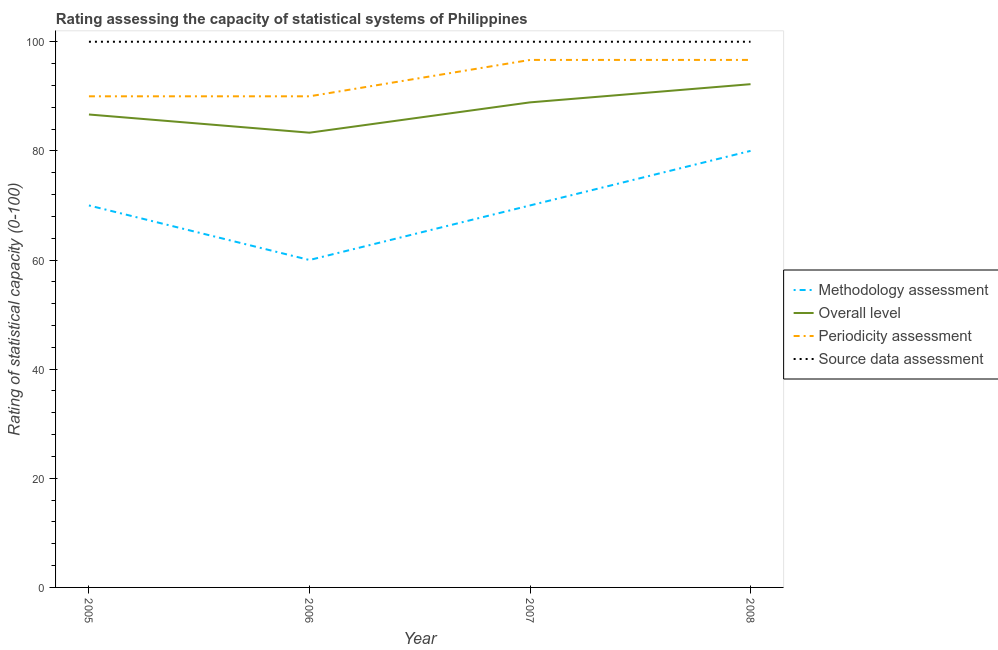Does the line corresponding to methodology assessment rating intersect with the line corresponding to overall level rating?
Your answer should be very brief. No. What is the source data assessment rating in 2008?
Provide a succinct answer. 100. Across all years, what is the maximum overall level rating?
Offer a very short reply. 92.22. Across all years, what is the minimum methodology assessment rating?
Offer a very short reply. 60. In which year was the periodicity assessment rating minimum?
Make the answer very short. 2005. What is the total methodology assessment rating in the graph?
Ensure brevity in your answer.  280. What is the difference between the source data assessment rating in 2006 and that in 2008?
Provide a succinct answer. 0. What is the difference between the overall level rating in 2007 and the periodicity assessment rating in 2008?
Ensure brevity in your answer.  -7.78. What is the average periodicity assessment rating per year?
Your response must be concise. 93.33. In how many years, is the overall level rating greater than 4?
Offer a terse response. 4. What is the ratio of the source data assessment rating in 2005 to that in 2007?
Offer a terse response. 1. Is the overall level rating in 2007 less than that in 2008?
Offer a terse response. Yes. Is the difference between the periodicity assessment rating in 2005 and 2006 greater than the difference between the methodology assessment rating in 2005 and 2006?
Provide a succinct answer. No. What is the difference between the highest and the lowest overall level rating?
Ensure brevity in your answer.  8.89. Is it the case that in every year, the sum of the methodology assessment rating and periodicity assessment rating is greater than the sum of source data assessment rating and overall level rating?
Offer a very short reply. Yes. Is the methodology assessment rating strictly less than the source data assessment rating over the years?
Your response must be concise. Yes. Are the values on the major ticks of Y-axis written in scientific E-notation?
Your answer should be compact. No. Where does the legend appear in the graph?
Provide a short and direct response. Center right. How are the legend labels stacked?
Keep it short and to the point. Vertical. What is the title of the graph?
Your response must be concise. Rating assessing the capacity of statistical systems of Philippines. What is the label or title of the X-axis?
Keep it short and to the point. Year. What is the label or title of the Y-axis?
Your answer should be very brief. Rating of statistical capacity (0-100). What is the Rating of statistical capacity (0-100) in Overall level in 2005?
Make the answer very short. 86.67. What is the Rating of statistical capacity (0-100) of Methodology assessment in 2006?
Your answer should be very brief. 60. What is the Rating of statistical capacity (0-100) of Overall level in 2006?
Provide a short and direct response. 83.33. What is the Rating of statistical capacity (0-100) of Periodicity assessment in 2006?
Your answer should be compact. 90. What is the Rating of statistical capacity (0-100) of Source data assessment in 2006?
Give a very brief answer. 100. What is the Rating of statistical capacity (0-100) of Methodology assessment in 2007?
Provide a succinct answer. 70. What is the Rating of statistical capacity (0-100) in Overall level in 2007?
Provide a short and direct response. 88.89. What is the Rating of statistical capacity (0-100) in Periodicity assessment in 2007?
Provide a short and direct response. 96.67. What is the Rating of statistical capacity (0-100) of Source data assessment in 2007?
Offer a terse response. 100. What is the Rating of statistical capacity (0-100) of Methodology assessment in 2008?
Give a very brief answer. 80. What is the Rating of statistical capacity (0-100) in Overall level in 2008?
Your answer should be very brief. 92.22. What is the Rating of statistical capacity (0-100) of Periodicity assessment in 2008?
Your answer should be very brief. 96.67. Across all years, what is the maximum Rating of statistical capacity (0-100) of Overall level?
Keep it short and to the point. 92.22. Across all years, what is the maximum Rating of statistical capacity (0-100) of Periodicity assessment?
Make the answer very short. 96.67. Across all years, what is the maximum Rating of statistical capacity (0-100) of Source data assessment?
Offer a terse response. 100. Across all years, what is the minimum Rating of statistical capacity (0-100) of Methodology assessment?
Offer a terse response. 60. Across all years, what is the minimum Rating of statistical capacity (0-100) of Overall level?
Your answer should be very brief. 83.33. Across all years, what is the minimum Rating of statistical capacity (0-100) in Source data assessment?
Give a very brief answer. 100. What is the total Rating of statistical capacity (0-100) of Methodology assessment in the graph?
Provide a short and direct response. 280. What is the total Rating of statistical capacity (0-100) of Overall level in the graph?
Your answer should be compact. 351.11. What is the total Rating of statistical capacity (0-100) in Periodicity assessment in the graph?
Your answer should be very brief. 373.33. What is the total Rating of statistical capacity (0-100) in Source data assessment in the graph?
Give a very brief answer. 400. What is the difference between the Rating of statistical capacity (0-100) of Methodology assessment in 2005 and that in 2006?
Your answer should be very brief. 10. What is the difference between the Rating of statistical capacity (0-100) in Overall level in 2005 and that in 2006?
Your answer should be compact. 3.33. What is the difference between the Rating of statistical capacity (0-100) in Methodology assessment in 2005 and that in 2007?
Your response must be concise. 0. What is the difference between the Rating of statistical capacity (0-100) in Overall level in 2005 and that in 2007?
Provide a short and direct response. -2.22. What is the difference between the Rating of statistical capacity (0-100) of Periodicity assessment in 2005 and that in 2007?
Offer a terse response. -6.67. What is the difference between the Rating of statistical capacity (0-100) of Source data assessment in 2005 and that in 2007?
Offer a terse response. 0. What is the difference between the Rating of statistical capacity (0-100) of Methodology assessment in 2005 and that in 2008?
Your answer should be very brief. -10. What is the difference between the Rating of statistical capacity (0-100) of Overall level in 2005 and that in 2008?
Your response must be concise. -5.56. What is the difference between the Rating of statistical capacity (0-100) of Periodicity assessment in 2005 and that in 2008?
Keep it short and to the point. -6.67. What is the difference between the Rating of statistical capacity (0-100) of Source data assessment in 2005 and that in 2008?
Give a very brief answer. 0. What is the difference between the Rating of statistical capacity (0-100) of Overall level in 2006 and that in 2007?
Make the answer very short. -5.56. What is the difference between the Rating of statistical capacity (0-100) of Periodicity assessment in 2006 and that in 2007?
Keep it short and to the point. -6.67. What is the difference between the Rating of statistical capacity (0-100) in Overall level in 2006 and that in 2008?
Make the answer very short. -8.89. What is the difference between the Rating of statistical capacity (0-100) of Periodicity assessment in 2006 and that in 2008?
Provide a short and direct response. -6.67. What is the difference between the Rating of statistical capacity (0-100) of Source data assessment in 2006 and that in 2008?
Give a very brief answer. 0. What is the difference between the Rating of statistical capacity (0-100) in Methodology assessment in 2007 and that in 2008?
Provide a short and direct response. -10. What is the difference between the Rating of statistical capacity (0-100) in Source data assessment in 2007 and that in 2008?
Ensure brevity in your answer.  0. What is the difference between the Rating of statistical capacity (0-100) in Methodology assessment in 2005 and the Rating of statistical capacity (0-100) in Overall level in 2006?
Ensure brevity in your answer.  -13.33. What is the difference between the Rating of statistical capacity (0-100) of Overall level in 2005 and the Rating of statistical capacity (0-100) of Source data assessment in 2006?
Ensure brevity in your answer.  -13.33. What is the difference between the Rating of statistical capacity (0-100) in Methodology assessment in 2005 and the Rating of statistical capacity (0-100) in Overall level in 2007?
Give a very brief answer. -18.89. What is the difference between the Rating of statistical capacity (0-100) in Methodology assessment in 2005 and the Rating of statistical capacity (0-100) in Periodicity assessment in 2007?
Your answer should be compact. -26.67. What is the difference between the Rating of statistical capacity (0-100) of Overall level in 2005 and the Rating of statistical capacity (0-100) of Source data assessment in 2007?
Your response must be concise. -13.33. What is the difference between the Rating of statistical capacity (0-100) of Periodicity assessment in 2005 and the Rating of statistical capacity (0-100) of Source data assessment in 2007?
Your answer should be very brief. -10. What is the difference between the Rating of statistical capacity (0-100) in Methodology assessment in 2005 and the Rating of statistical capacity (0-100) in Overall level in 2008?
Offer a terse response. -22.22. What is the difference between the Rating of statistical capacity (0-100) of Methodology assessment in 2005 and the Rating of statistical capacity (0-100) of Periodicity assessment in 2008?
Make the answer very short. -26.67. What is the difference between the Rating of statistical capacity (0-100) of Methodology assessment in 2005 and the Rating of statistical capacity (0-100) of Source data assessment in 2008?
Provide a succinct answer. -30. What is the difference between the Rating of statistical capacity (0-100) of Overall level in 2005 and the Rating of statistical capacity (0-100) of Source data assessment in 2008?
Provide a short and direct response. -13.33. What is the difference between the Rating of statistical capacity (0-100) in Methodology assessment in 2006 and the Rating of statistical capacity (0-100) in Overall level in 2007?
Your answer should be compact. -28.89. What is the difference between the Rating of statistical capacity (0-100) in Methodology assessment in 2006 and the Rating of statistical capacity (0-100) in Periodicity assessment in 2007?
Make the answer very short. -36.67. What is the difference between the Rating of statistical capacity (0-100) of Overall level in 2006 and the Rating of statistical capacity (0-100) of Periodicity assessment in 2007?
Ensure brevity in your answer.  -13.33. What is the difference between the Rating of statistical capacity (0-100) of Overall level in 2006 and the Rating of statistical capacity (0-100) of Source data assessment in 2007?
Give a very brief answer. -16.67. What is the difference between the Rating of statistical capacity (0-100) in Methodology assessment in 2006 and the Rating of statistical capacity (0-100) in Overall level in 2008?
Your answer should be compact. -32.22. What is the difference between the Rating of statistical capacity (0-100) in Methodology assessment in 2006 and the Rating of statistical capacity (0-100) in Periodicity assessment in 2008?
Your answer should be compact. -36.67. What is the difference between the Rating of statistical capacity (0-100) of Overall level in 2006 and the Rating of statistical capacity (0-100) of Periodicity assessment in 2008?
Offer a terse response. -13.33. What is the difference between the Rating of statistical capacity (0-100) in Overall level in 2006 and the Rating of statistical capacity (0-100) in Source data assessment in 2008?
Offer a terse response. -16.67. What is the difference between the Rating of statistical capacity (0-100) of Periodicity assessment in 2006 and the Rating of statistical capacity (0-100) of Source data assessment in 2008?
Keep it short and to the point. -10. What is the difference between the Rating of statistical capacity (0-100) of Methodology assessment in 2007 and the Rating of statistical capacity (0-100) of Overall level in 2008?
Give a very brief answer. -22.22. What is the difference between the Rating of statistical capacity (0-100) in Methodology assessment in 2007 and the Rating of statistical capacity (0-100) in Periodicity assessment in 2008?
Offer a very short reply. -26.67. What is the difference between the Rating of statistical capacity (0-100) in Overall level in 2007 and the Rating of statistical capacity (0-100) in Periodicity assessment in 2008?
Offer a terse response. -7.78. What is the difference between the Rating of statistical capacity (0-100) of Overall level in 2007 and the Rating of statistical capacity (0-100) of Source data assessment in 2008?
Ensure brevity in your answer.  -11.11. What is the difference between the Rating of statistical capacity (0-100) of Periodicity assessment in 2007 and the Rating of statistical capacity (0-100) of Source data assessment in 2008?
Give a very brief answer. -3.33. What is the average Rating of statistical capacity (0-100) of Methodology assessment per year?
Your answer should be compact. 70. What is the average Rating of statistical capacity (0-100) in Overall level per year?
Your response must be concise. 87.78. What is the average Rating of statistical capacity (0-100) in Periodicity assessment per year?
Keep it short and to the point. 93.33. In the year 2005, what is the difference between the Rating of statistical capacity (0-100) in Methodology assessment and Rating of statistical capacity (0-100) in Overall level?
Your answer should be very brief. -16.67. In the year 2005, what is the difference between the Rating of statistical capacity (0-100) of Methodology assessment and Rating of statistical capacity (0-100) of Periodicity assessment?
Make the answer very short. -20. In the year 2005, what is the difference between the Rating of statistical capacity (0-100) of Overall level and Rating of statistical capacity (0-100) of Source data assessment?
Your response must be concise. -13.33. In the year 2006, what is the difference between the Rating of statistical capacity (0-100) in Methodology assessment and Rating of statistical capacity (0-100) in Overall level?
Your response must be concise. -23.33. In the year 2006, what is the difference between the Rating of statistical capacity (0-100) of Methodology assessment and Rating of statistical capacity (0-100) of Source data assessment?
Give a very brief answer. -40. In the year 2006, what is the difference between the Rating of statistical capacity (0-100) in Overall level and Rating of statistical capacity (0-100) in Periodicity assessment?
Provide a short and direct response. -6.67. In the year 2006, what is the difference between the Rating of statistical capacity (0-100) in Overall level and Rating of statistical capacity (0-100) in Source data assessment?
Your response must be concise. -16.67. In the year 2007, what is the difference between the Rating of statistical capacity (0-100) in Methodology assessment and Rating of statistical capacity (0-100) in Overall level?
Make the answer very short. -18.89. In the year 2007, what is the difference between the Rating of statistical capacity (0-100) of Methodology assessment and Rating of statistical capacity (0-100) of Periodicity assessment?
Offer a very short reply. -26.67. In the year 2007, what is the difference between the Rating of statistical capacity (0-100) in Overall level and Rating of statistical capacity (0-100) in Periodicity assessment?
Offer a very short reply. -7.78. In the year 2007, what is the difference between the Rating of statistical capacity (0-100) of Overall level and Rating of statistical capacity (0-100) of Source data assessment?
Your response must be concise. -11.11. In the year 2007, what is the difference between the Rating of statistical capacity (0-100) in Periodicity assessment and Rating of statistical capacity (0-100) in Source data assessment?
Provide a succinct answer. -3.33. In the year 2008, what is the difference between the Rating of statistical capacity (0-100) in Methodology assessment and Rating of statistical capacity (0-100) in Overall level?
Offer a very short reply. -12.22. In the year 2008, what is the difference between the Rating of statistical capacity (0-100) of Methodology assessment and Rating of statistical capacity (0-100) of Periodicity assessment?
Give a very brief answer. -16.67. In the year 2008, what is the difference between the Rating of statistical capacity (0-100) in Overall level and Rating of statistical capacity (0-100) in Periodicity assessment?
Give a very brief answer. -4.44. In the year 2008, what is the difference between the Rating of statistical capacity (0-100) in Overall level and Rating of statistical capacity (0-100) in Source data assessment?
Make the answer very short. -7.78. In the year 2008, what is the difference between the Rating of statistical capacity (0-100) of Periodicity assessment and Rating of statistical capacity (0-100) of Source data assessment?
Provide a short and direct response. -3.33. What is the ratio of the Rating of statistical capacity (0-100) of Methodology assessment in 2005 to that in 2006?
Ensure brevity in your answer.  1.17. What is the ratio of the Rating of statistical capacity (0-100) of Overall level in 2005 to that in 2006?
Give a very brief answer. 1.04. What is the ratio of the Rating of statistical capacity (0-100) of Source data assessment in 2005 to that in 2006?
Offer a terse response. 1. What is the ratio of the Rating of statistical capacity (0-100) of Overall level in 2005 to that in 2008?
Keep it short and to the point. 0.94. What is the ratio of the Rating of statistical capacity (0-100) in Periodicity assessment in 2005 to that in 2008?
Offer a terse response. 0.93. What is the ratio of the Rating of statistical capacity (0-100) in Source data assessment in 2005 to that in 2008?
Your answer should be very brief. 1. What is the ratio of the Rating of statistical capacity (0-100) in Methodology assessment in 2006 to that in 2007?
Your answer should be very brief. 0.86. What is the ratio of the Rating of statistical capacity (0-100) in Overall level in 2006 to that in 2007?
Ensure brevity in your answer.  0.94. What is the ratio of the Rating of statistical capacity (0-100) of Source data assessment in 2006 to that in 2007?
Your response must be concise. 1. What is the ratio of the Rating of statistical capacity (0-100) in Methodology assessment in 2006 to that in 2008?
Offer a terse response. 0.75. What is the ratio of the Rating of statistical capacity (0-100) of Overall level in 2006 to that in 2008?
Provide a succinct answer. 0.9. What is the ratio of the Rating of statistical capacity (0-100) of Periodicity assessment in 2006 to that in 2008?
Provide a short and direct response. 0.93. What is the ratio of the Rating of statistical capacity (0-100) of Source data assessment in 2006 to that in 2008?
Your answer should be compact. 1. What is the ratio of the Rating of statistical capacity (0-100) of Overall level in 2007 to that in 2008?
Keep it short and to the point. 0.96. What is the ratio of the Rating of statistical capacity (0-100) in Source data assessment in 2007 to that in 2008?
Keep it short and to the point. 1. What is the difference between the highest and the second highest Rating of statistical capacity (0-100) of Source data assessment?
Your answer should be very brief. 0. What is the difference between the highest and the lowest Rating of statistical capacity (0-100) of Overall level?
Your answer should be compact. 8.89. What is the difference between the highest and the lowest Rating of statistical capacity (0-100) of Periodicity assessment?
Provide a succinct answer. 6.67. 